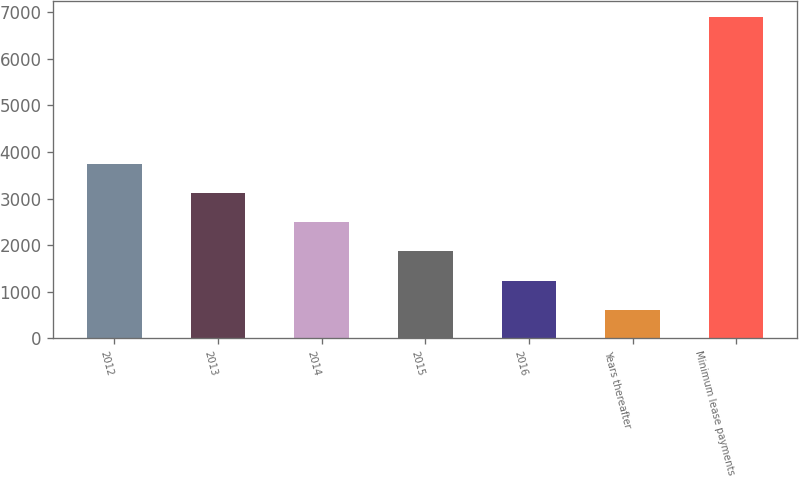<chart> <loc_0><loc_0><loc_500><loc_500><bar_chart><fcel>2012<fcel>2013<fcel>2014<fcel>2015<fcel>2016<fcel>Years thereafter<fcel>Minimum lease payments<nl><fcel>3747.5<fcel>3118.8<fcel>2490.1<fcel>1861.4<fcel>1232.7<fcel>604<fcel>6891<nl></chart> 